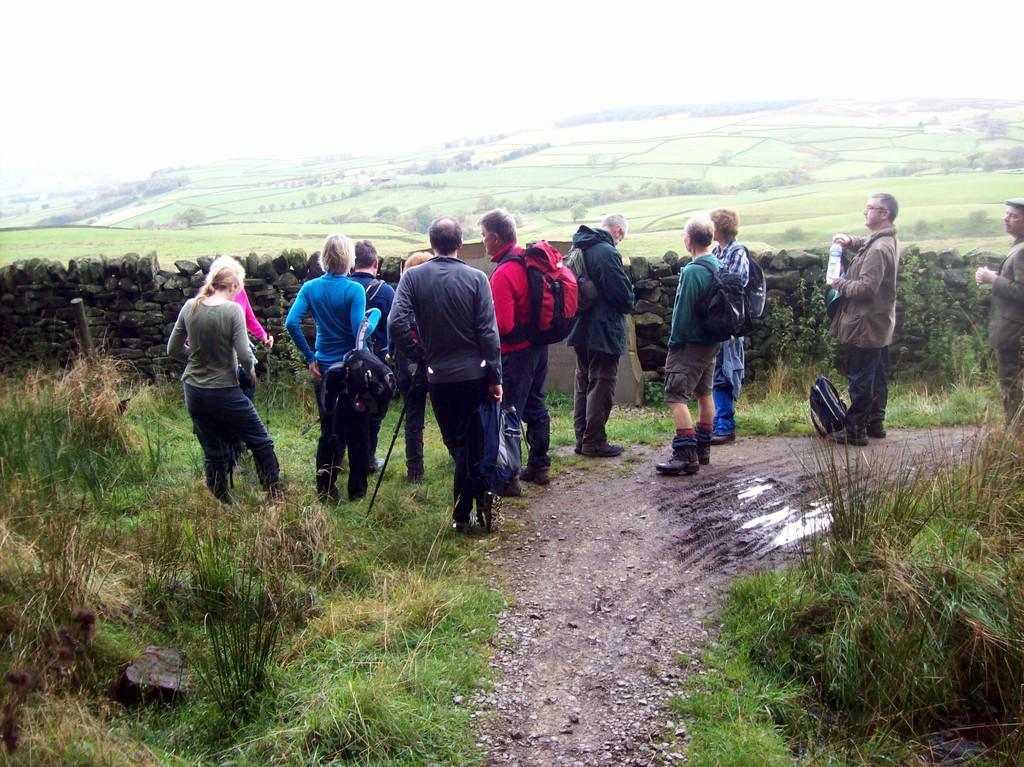What are the people in the image doing? The people in the image are standing. What are some of the people carrying? Some of the people are carrying bags. What can be seen in the image besides the people? Water, a fence wall, grass, trees, and the sky are visible in the image. Can you see any crowns on the people's heads in the image? There are no crowns visible on the people's heads in the image. 